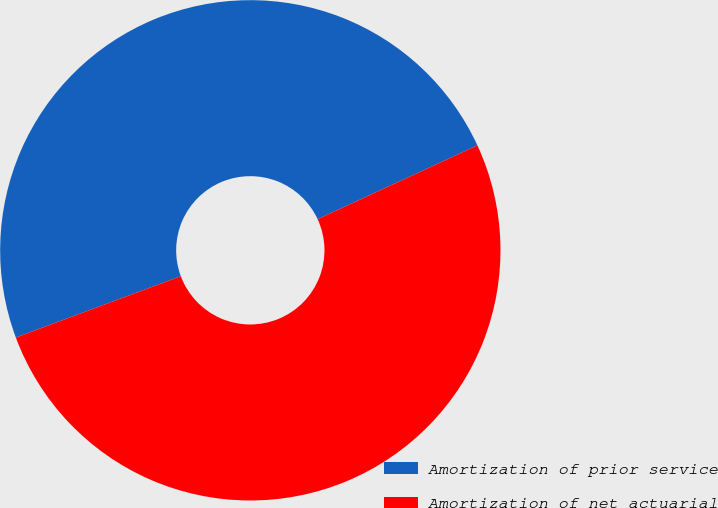Convert chart to OTSL. <chart><loc_0><loc_0><loc_500><loc_500><pie_chart><fcel>Amortization of prior service<fcel>Amortization of net actuarial<nl><fcel>48.78%<fcel>51.22%<nl></chart> 